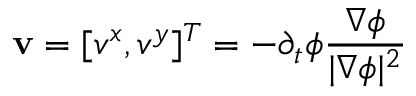<formula> <loc_0><loc_0><loc_500><loc_500>v = [ v ^ { x } , v ^ { y } ] ^ { T } = - \partial _ { t } \phi \frac { \nabla \phi } { | \nabla \phi | ^ { 2 } }</formula> 